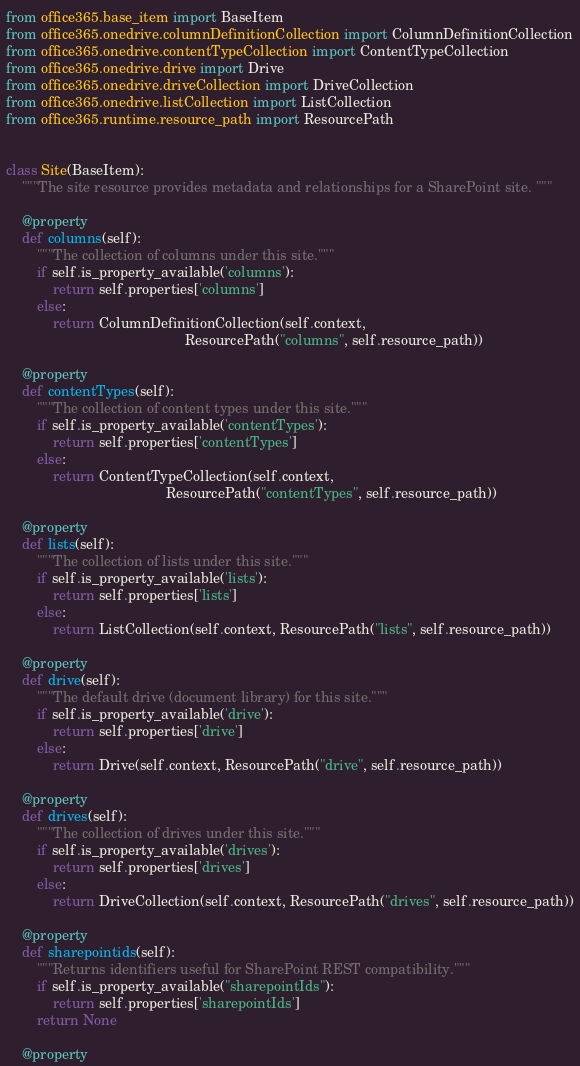Convert code to text. <code><loc_0><loc_0><loc_500><loc_500><_Python_>from office365.base_item import BaseItem
from office365.onedrive.columnDefinitionCollection import ColumnDefinitionCollection
from office365.onedrive.contentTypeCollection import ContentTypeCollection
from office365.onedrive.drive import Drive
from office365.onedrive.driveCollection import DriveCollection
from office365.onedrive.listCollection import ListCollection
from office365.runtime.resource_path import ResourcePath


class Site(BaseItem):
    """The site resource provides metadata and relationships for a SharePoint site. """

    @property
    def columns(self):
        """The collection of columns under this site."""
        if self.is_property_available('columns'):
            return self.properties['columns']
        else:
            return ColumnDefinitionCollection(self.context,
                                              ResourcePath("columns", self.resource_path))

    @property
    def contentTypes(self):
        """The collection of content types under this site."""
        if self.is_property_available('contentTypes'):
            return self.properties['contentTypes']
        else:
            return ContentTypeCollection(self.context,
                                         ResourcePath("contentTypes", self.resource_path))

    @property
    def lists(self):
        """The collection of lists under this site."""
        if self.is_property_available('lists'):
            return self.properties['lists']
        else:
            return ListCollection(self.context, ResourcePath("lists", self.resource_path))

    @property
    def drive(self):
        """The default drive (document library) for this site."""
        if self.is_property_available('drive'):
            return self.properties['drive']
        else:
            return Drive(self.context, ResourcePath("drive", self.resource_path))

    @property
    def drives(self):
        """The collection of drives under this site."""
        if self.is_property_available('drives'):
            return self.properties['drives']
        else:
            return DriveCollection(self.context, ResourcePath("drives", self.resource_path))

    @property
    def sharepointids(self):
        """Returns identifiers useful for SharePoint REST compatibility."""
        if self.is_property_available("sharepointIds"):
            return self.properties['sharepointIds']
        return None

    @property</code> 